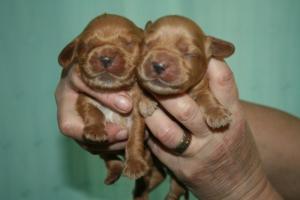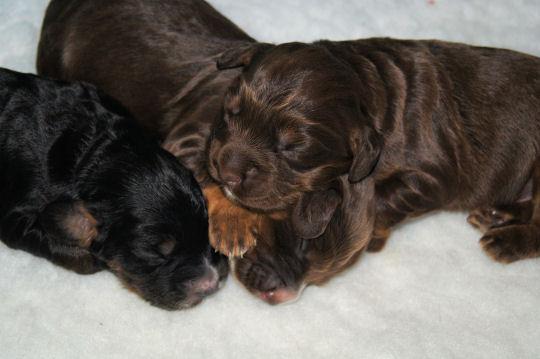The first image is the image on the left, the second image is the image on the right. Considering the images on both sides, is "There are two dogs in the lefthand image." valid? Answer yes or no. Yes. The first image is the image on the left, the second image is the image on the right. For the images shown, is this caption "All of the pups are sleeping." true? Answer yes or no. Yes. 